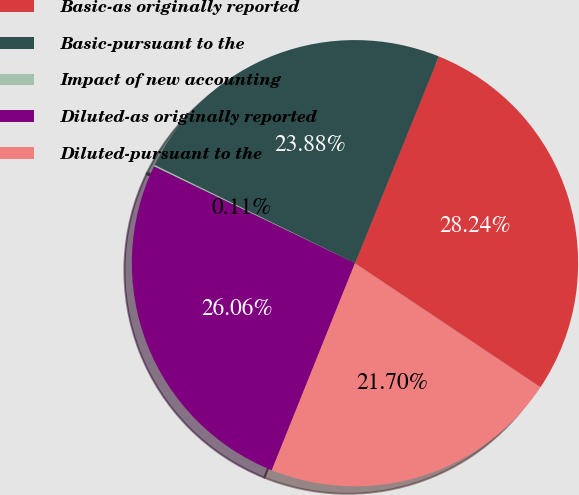<chart> <loc_0><loc_0><loc_500><loc_500><pie_chart><fcel>Basic-as originally reported<fcel>Basic-pursuant to the<fcel>Impact of new accounting<fcel>Diluted-as originally reported<fcel>Diluted-pursuant to the<nl><fcel>28.24%<fcel>23.88%<fcel>0.11%<fcel>26.06%<fcel>21.7%<nl></chart> 